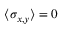Convert formula to latex. <formula><loc_0><loc_0><loc_500><loc_500>\langle \sigma _ { x , y } \rangle = 0</formula> 